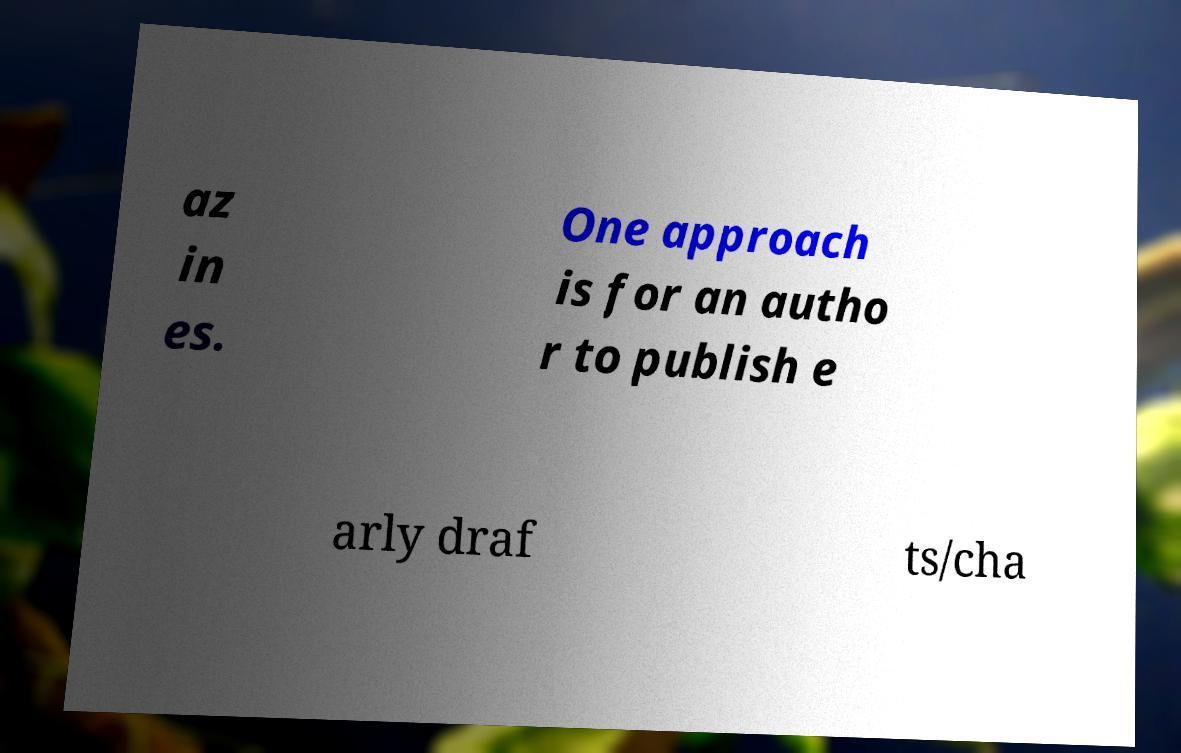Please read and relay the text visible in this image. What does it say? az in es. One approach is for an autho r to publish e arly draf ts/cha 